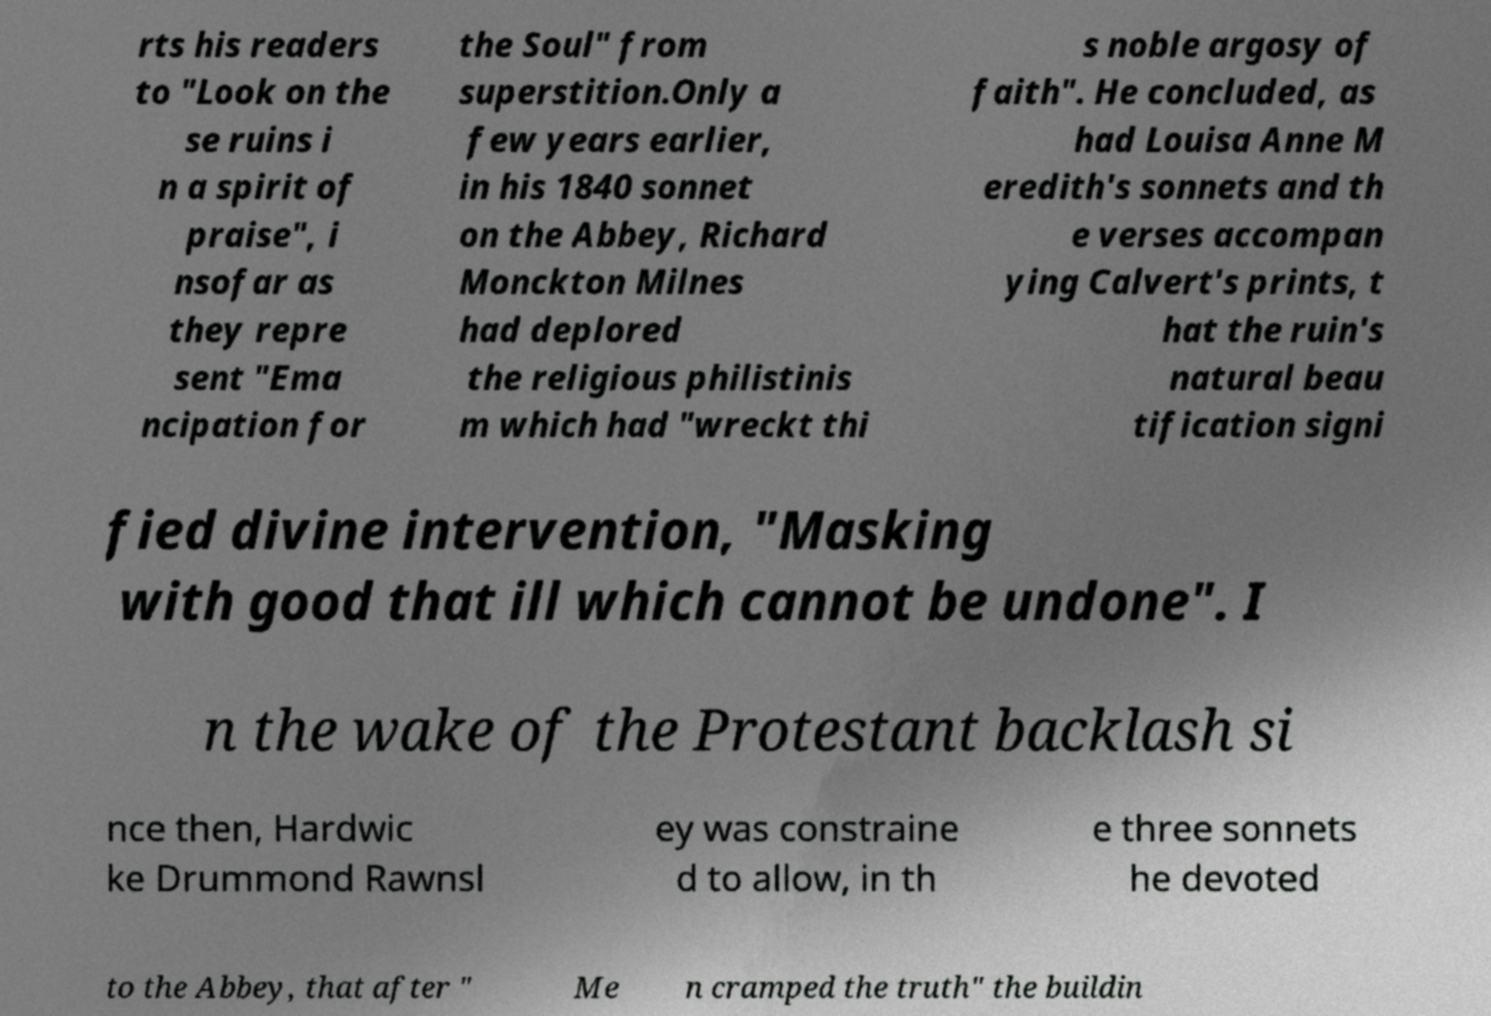Please identify and transcribe the text found in this image. rts his readers to "Look on the se ruins i n a spirit of praise", i nsofar as they repre sent "Ema ncipation for the Soul" from superstition.Only a few years earlier, in his 1840 sonnet on the Abbey, Richard Monckton Milnes had deplored the religious philistinis m which had "wreckt thi s noble argosy of faith". He concluded, as had Louisa Anne M eredith's sonnets and th e verses accompan ying Calvert's prints, t hat the ruin's natural beau tification signi fied divine intervention, "Masking with good that ill which cannot be undone". I n the wake of the Protestant backlash si nce then, Hardwic ke Drummond Rawnsl ey was constraine d to allow, in th e three sonnets he devoted to the Abbey, that after " Me n cramped the truth" the buildin 